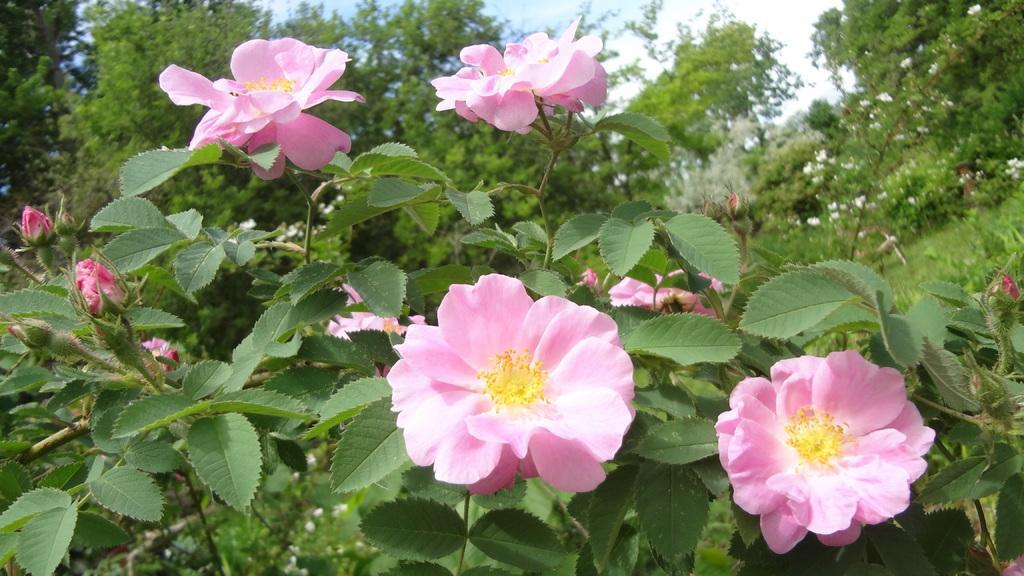Could you give a brief overview of what you see in this image? This is a zoomed in picture which is clicked outside. In the center we can see the flowers and buds and we can see the leaves. In the background there is a sky, trees and flowers. 